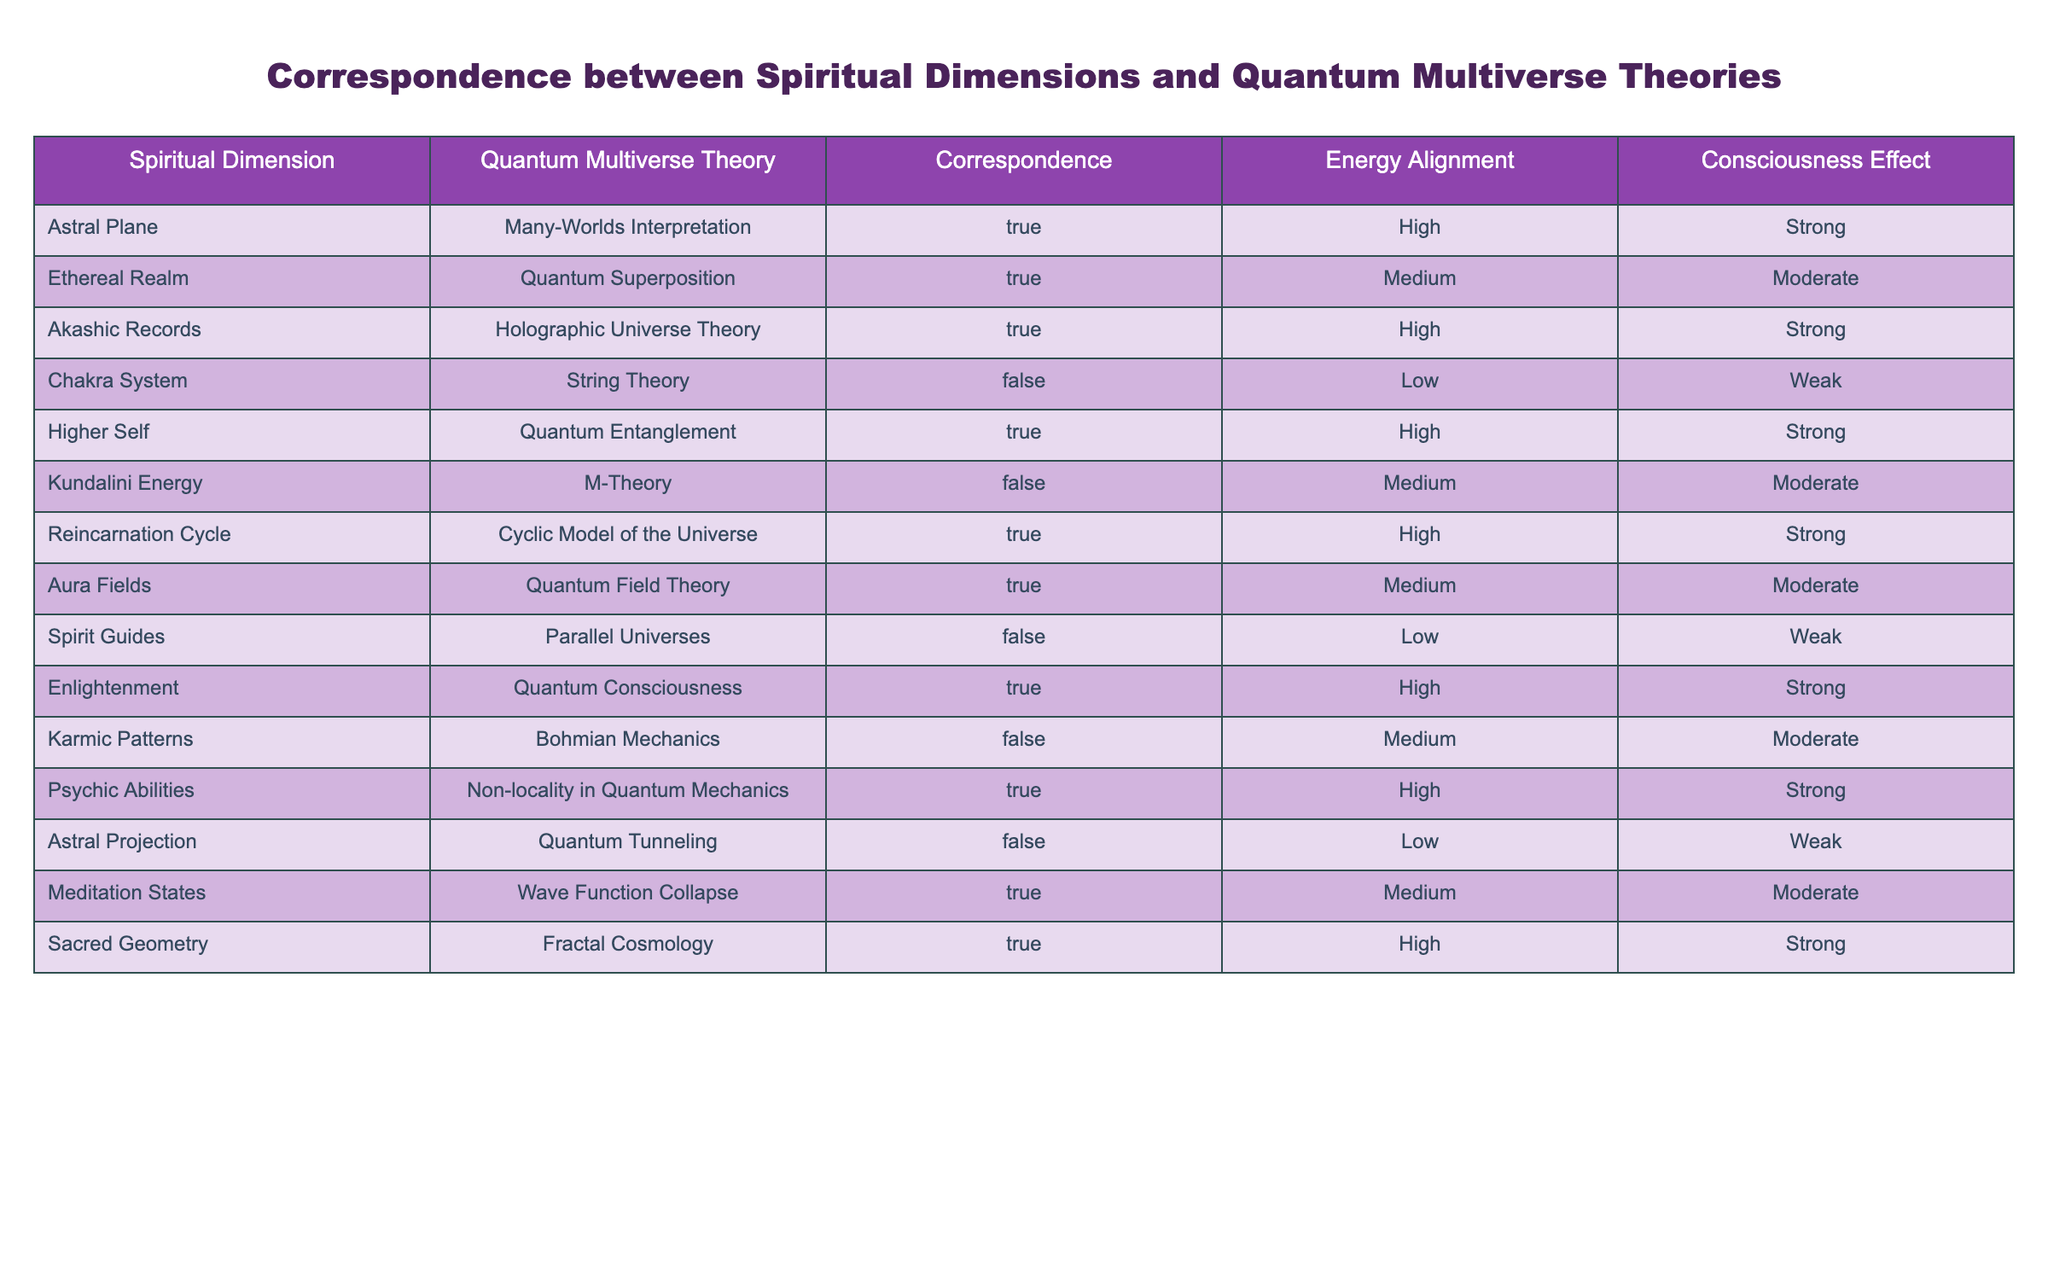What is the correspondence status of the Astral Plane in relation to the Many-Worlds Interpretation? The table indicates that the correspondence between the Astral Plane and the Many-Worlds Interpretation is marked as True.
Answer: True How many spiritual dimensions correspond to the Holographic Universe Theory? From the table, only the Akashic Records are associated with the Holographic Universe Theory. Thus, there is 1 spiritual dimension.
Answer: 1 Is there a correspondence between the Chakra System and any quantum multiverse theory? According to the table, the chakra system has a correspondence indicated as False with String Theory, meaning there is no correspondence to any quantum multiverse theory.
Answer: No What is the average energy alignment level for spiritual dimensions that have a true correspondence with quantum multiverse theories? The spiritual dimensions with a True correspondence are Astral Plane, Ethereal Realm, Akashic Records, Higher Self, Reincarnation Cycle, Aura Fields, Enlightenment, Psychic Abilities, Meditation States, and Sacred Geometry. Their energy alignments are High, Medium, High, High, High, Medium, High, High, Medium, High. Converting these to numerical values (High=3, Medium=2, Low=1) gives: (3 + 2 + 3 + 3 + 3 + 2 + 3 + 3 + 2 + 3) = 28. There are 10 data points, so the average is 28/10 = 2.8, which indicates a high average alignment.
Answer: 2.8 Which spiritual dimensions are associated with a Strong consciousness effect? The spiritual dimensions that are aligned with a Strong consciousness effect are the Astral Plane, Akashic Records, Higher Self, Enlightenment, Psychic Abilities, and Sacred Geometry. These can be found by looking for the "Strong" status in the consciousness effect column.
Answer: Astral Plane, Akashic Records, Higher Self, Enlightenment, Psychic Abilities, Sacred Geometry 